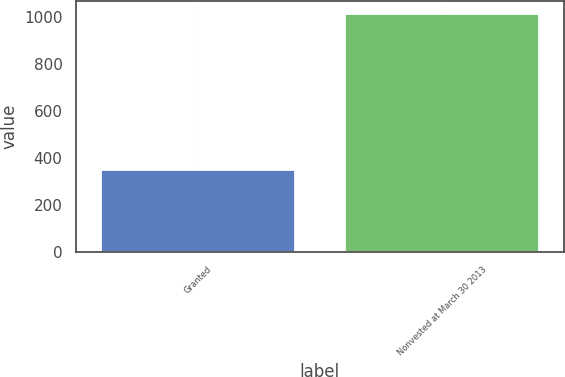<chart> <loc_0><loc_0><loc_500><loc_500><bar_chart><fcel>Granted<fcel>Nonvested at March 30 2013<nl><fcel>351<fcel>1015<nl></chart> 